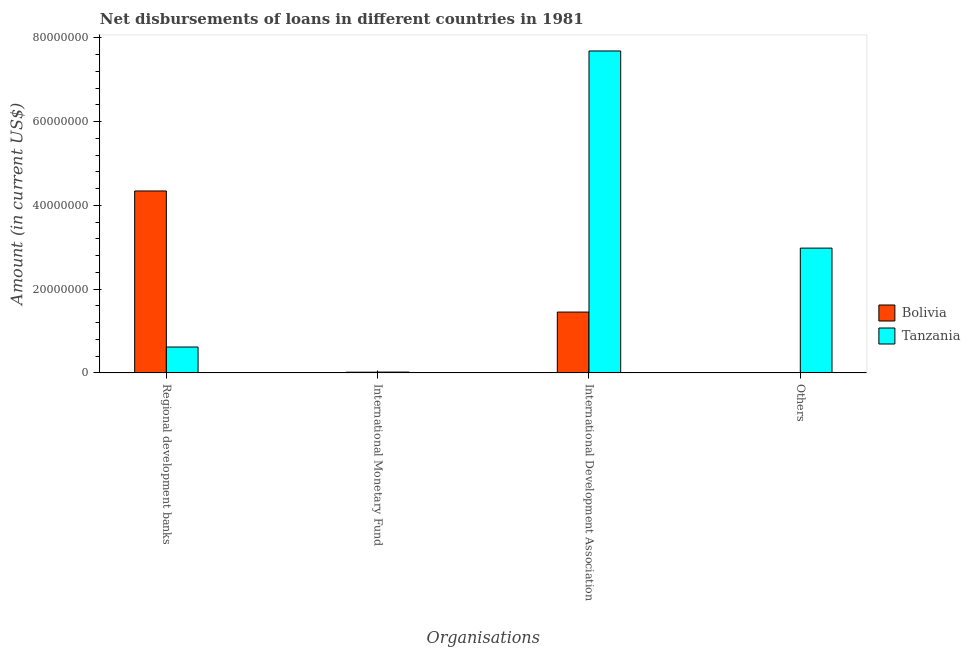How many different coloured bars are there?
Your response must be concise. 2. Are the number of bars per tick equal to the number of legend labels?
Your answer should be compact. Yes. How many bars are there on the 1st tick from the left?
Provide a short and direct response. 2. What is the label of the 4th group of bars from the left?
Ensure brevity in your answer.  Others. What is the amount of loan disimbursed by international development association in Tanzania?
Offer a terse response. 7.69e+07. Across all countries, what is the maximum amount of loan disimbursed by other organisations?
Your answer should be compact. 2.98e+07. Across all countries, what is the minimum amount of loan disimbursed by other organisations?
Provide a succinct answer. 1.20e+04. In which country was the amount of loan disimbursed by international monetary fund maximum?
Offer a very short reply. Tanzania. What is the total amount of loan disimbursed by international monetary fund in the graph?
Your response must be concise. 3.53e+05. What is the difference between the amount of loan disimbursed by international development association in Tanzania and that in Bolivia?
Your answer should be compact. 6.23e+07. What is the difference between the amount of loan disimbursed by international development association in Tanzania and the amount of loan disimbursed by other organisations in Bolivia?
Make the answer very short. 7.69e+07. What is the average amount of loan disimbursed by regional development banks per country?
Give a very brief answer. 2.48e+07. What is the difference between the amount of loan disimbursed by international development association and amount of loan disimbursed by regional development banks in Bolivia?
Keep it short and to the point. -2.89e+07. What is the ratio of the amount of loan disimbursed by international monetary fund in Tanzania to that in Bolivia?
Make the answer very short. 1.14. Is the difference between the amount of loan disimbursed by regional development banks in Tanzania and Bolivia greater than the difference between the amount of loan disimbursed by international development association in Tanzania and Bolivia?
Your answer should be very brief. No. What is the difference between the highest and the second highest amount of loan disimbursed by international monetary fund?
Your answer should be compact. 2.30e+04. What is the difference between the highest and the lowest amount of loan disimbursed by other organisations?
Provide a short and direct response. 2.98e+07. What does the 2nd bar from the left in International Monetary Fund represents?
Make the answer very short. Tanzania. Is it the case that in every country, the sum of the amount of loan disimbursed by regional development banks and amount of loan disimbursed by international monetary fund is greater than the amount of loan disimbursed by international development association?
Provide a short and direct response. No. Are all the bars in the graph horizontal?
Offer a very short reply. No. Does the graph contain grids?
Your answer should be very brief. No. How many legend labels are there?
Make the answer very short. 2. What is the title of the graph?
Offer a terse response. Net disbursements of loans in different countries in 1981. Does "Singapore" appear as one of the legend labels in the graph?
Offer a very short reply. No. What is the label or title of the X-axis?
Your answer should be very brief. Organisations. What is the label or title of the Y-axis?
Keep it short and to the point. Amount (in current US$). What is the Amount (in current US$) of Bolivia in Regional development banks?
Your response must be concise. 4.34e+07. What is the Amount (in current US$) in Tanzania in Regional development banks?
Your answer should be very brief. 6.17e+06. What is the Amount (in current US$) of Bolivia in International Monetary Fund?
Your answer should be compact. 1.65e+05. What is the Amount (in current US$) in Tanzania in International Monetary Fund?
Provide a short and direct response. 1.88e+05. What is the Amount (in current US$) of Bolivia in International Development Association?
Offer a very short reply. 1.45e+07. What is the Amount (in current US$) in Tanzania in International Development Association?
Provide a succinct answer. 7.69e+07. What is the Amount (in current US$) of Bolivia in Others?
Provide a succinct answer. 1.20e+04. What is the Amount (in current US$) in Tanzania in Others?
Offer a very short reply. 2.98e+07. Across all Organisations, what is the maximum Amount (in current US$) of Bolivia?
Your response must be concise. 4.34e+07. Across all Organisations, what is the maximum Amount (in current US$) of Tanzania?
Provide a succinct answer. 7.69e+07. Across all Organisations, what is the minimum Amount (in current US$) of Bolivia?
Provide a succinct answer. 1.20e+04. Across all Organisations, what is the minimum Amount (in current US$) of Tanzania?
Keep it short and to the point. 1.88e+05. What is the total Amount (in current US$) of Bolivia in the graph?
Offer a very short reply. 5.81e+07. What is the total Amount (in current US$) of Tanzania in the graph?
Give a very brief answer. 1.13e+08. What is the difference between the Amount (in current US$) in Bolivia in Regional development banks and that in International Monetary Fund?
Your answer should be very brief. 4.33e+07. What is the difference between the Amount (in current US$) of Tanzania in Regional development banks and that in International Monetary Fund?
Your answer should be compact. 5.98e+06. What is the difference between the Amount (in current US$) of Bolivia in Regional development banks and that in International Development Association?
Give a very brief answer. 2.89e+07. What is the difference between the Amount (in current US$) in Tanzania in Regional development banks and that in International Development Association?
Offer a terse response. -7.07e+07. What is the difference between the Amount (in current US$) of Bolivia in Regional development banks and that in Others?
Provide a succinct answer. 4.34e+07. What is the difference between the Amount (in current US$) in Tanzania in Regional development banks and that in Others?
Ensure brevity in your answer.  -2.36e+07. What is the difference between the Amount (in current US$) in Bolivia in International Monetary Fund and that in International Development Association?
Provide a succinct answer. -1.44e+07. What is the difference between the Amount (in current US$) of Tanzania in International Monetary Fund and that in International Development Association?
Your answer should be compact. -7.67e+07. What is the difference between the Amount (in current US$) in Bolivia in International Monetary Fund and that in Others?
Offer a very short reply. 1.53e+05. What is the difference between the Amount (in current US$) of Tanzania in International Monetary Fund and that in Others?
Your response must be concise. -2.96e+07. What is the difference between the Amount (in current US$) in Bolivia in International Development Association and that in Others?
Your answer should be very brief. 1.45e+07. What is the difference between the Amount (in current US$) in Tanzania in International Development Association and that in Others?
Keep it short and to the point. 4.71e+07. What is the difference between the Amount (in current US$) of Bolivia in Regional development banks and the Amount (in current US$) of Tanzania in International Monetary Fund?
Give a very brief answer. 4.32e+07. What is the difference between the Amount (in current US$) in Bolivia in Regional development banks and the Amount (in current US$) in Tanzania in International Development Association?
Your response must be concise. -3.34e+07. What is the difference between the Amount (in current US$) of Bolivia in Regional development banks and the Amount (in current US$) of Tanzania in Others?
Provide a short and direct response. 1.36e+07. What is the difference between the Amount (in current US$) in Bolivia in International Monetary Fund and the Amount (in current US$) in Tanzania in International Development Association?
Your response must be concise. -7.67e+07. What is the difference between the Amount (in current US$) in Bolivia in International Monetary Fund and the Amount (in current US$) in Tanzania in Others?
Give a very brief answer. -2.96e+07. What is the difference between the Amount (in current US$) in Bolivia in International Development Association and the Amount (in current US$) in Tanzania in Others?
Offer a terse response. -1.53e+07. What is the average Amount (in current US$) of Bolivia per Organisations?
Ensure brevity in your answer.  1.45e+07. What is the average Amount (in current US$) in Tanzania per Organisations?
Your answer should be compact. 2.83e+07. What is the difference between the Amount (in current US$) in Bolivia and Amount (in current US$) in Tanzania in Regional development banks?
Ensure brevity in your answer.  3.73e+07. What is the difference between the Amount (in current US$) of Bolivia and Amount (in current US$) of Tanzania in International Monetary Fund?
Your response must be concise. -2.30e+04. What is the difference between the Amount (in current US$) of Bolivia and Amount (in current US$) of Tanzania in International Development Association?
Give a very brief answer. -6.23e+07. What is the difference between the Amount (in current US$) in Bolivia and Amount (in current US$) in Tanzania in Others?
Your answer should be compact. -2.98e+07. What is the ratio of the Amount (in current US$) of Bolivia in Regional development banks to that in International Monetary Fund?
Your answer should be compact. 263.25. What is the ratio of the Amount (in current US$) of Tanzania in Regional development banks to that in International Monetary Fund?
Your answer should be very brief. 32.82. What is the ratio of the Amount (in current US$) in Bolivia in Regional development banks to that in International Development Association?
Provide a succinct answer. 2.99. What is the ratio of the Amount (in current US$) in Tanzania in Regional development banks to that in International Development Association?
Make the answer very short. 0.08. What is the ratio of the Amount (in current US$) of Bolivia in Regional development banks to that in Others?
Your response must be concise. 3619.75. What is the ratio of the Amount (in current US$) of Tanzania in Regional development banks to that in Others?
Ensure brevity in your answer.  0.21. What is the ratio of the Amount (in current US$) in Bolivia in International Monetary Fund to that in International Development Association?
Keep it short and to the point. 0.01. What is the ratio of the Amount (in current US$) in Tanzania in International Monetary Fund to that in International Development Association?
Keep it short and to the point. 0. What is the ratio of the Amount (in current US$) in Bolivia in International Monetary Fund to that in Others?
Give a very brief answer. 13.75. What is the ratio of the Amount (in current US$) of Tanzania in International Monetary Fund to that in Others?
Make the answer very short. 0.01. What is the ratio of the Amount (in current US$) of Bolivia in International Development Association to that in Others?
Your response must be concise. 1209.83. What is the ratio of the Amount (in current US$) in Tanzania in International Development Association to that in Others?
Keep it short and to the point. 2.58. What is the difference between the highest and the second highest Amount (in current US$) of Bolivia?
Keep it short and to the point. 2.89e+07. What is the difference between the highest and the second highest Amount (in current US$) of Tanzania?
Your answer should be compact. 4.71e+07. What is the difference between the highest and the lowest Amount (in current US$) of Bolivia?
Ensure brevity in your answer.  4.34e+07. What is the difference between the highest and the lowest Amount (in current US$) of Tanzania?
Your response must be concise. 7.67e+07. 